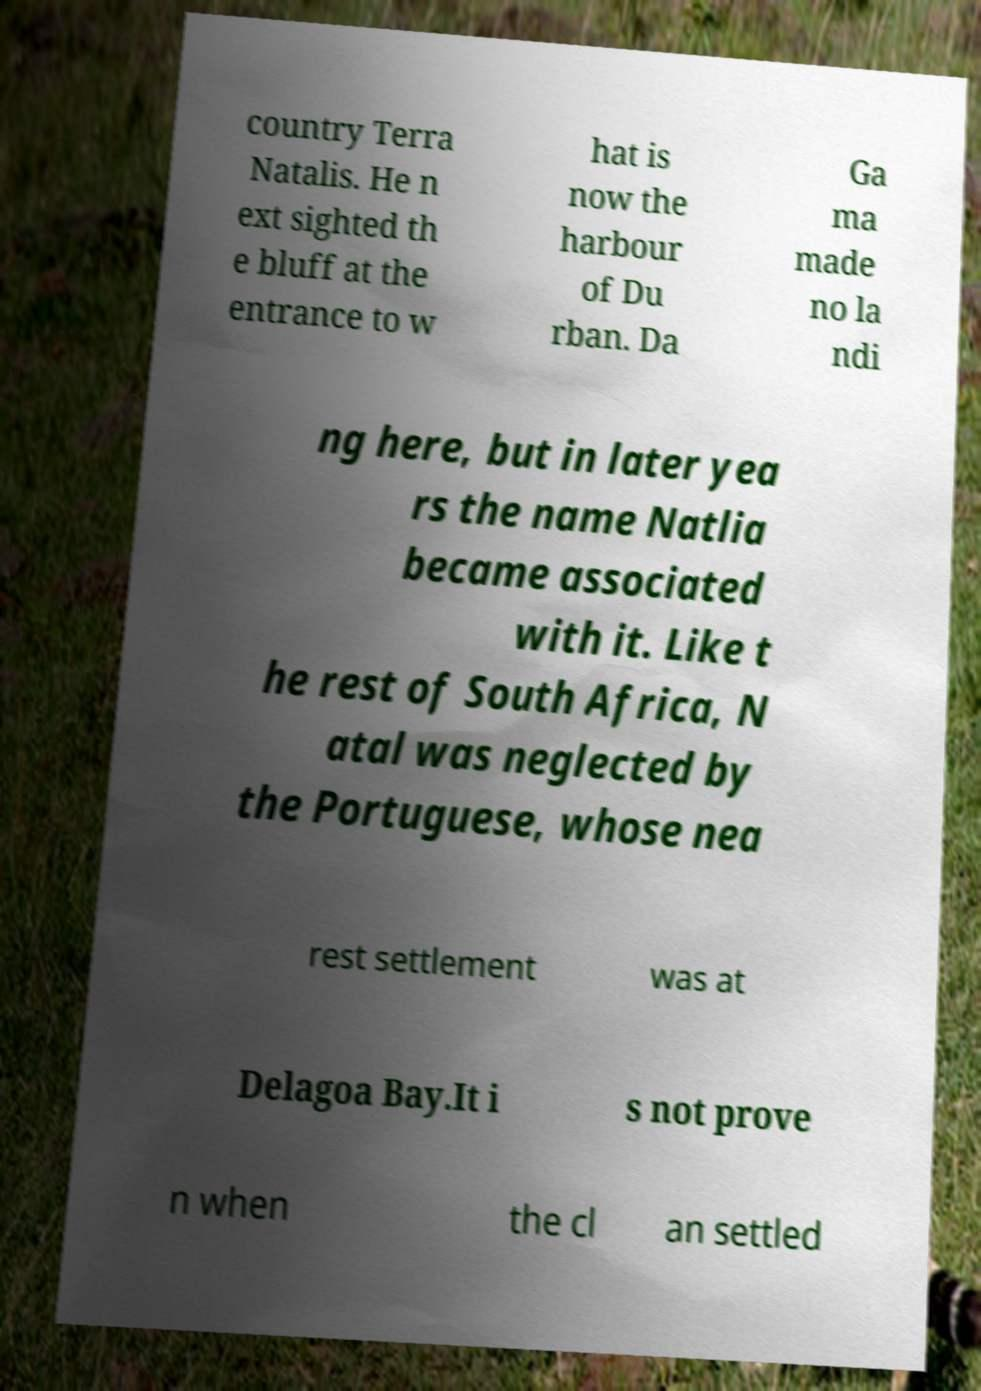Please identify and transcribe the text found in this image. country Terra Natalis. He n ext sighted th e bluff at the entrance to w hat is now the harbour of Du rban. Da Ga ma made no la ndi ng here, but in later yea rs the name Natlia became associated with it. Like t he rest of South Africa, N atal was neglected by the Portuguese, whose nea rest settlement was at Delagoa Bay.It i s not prove n when the cl an settled 